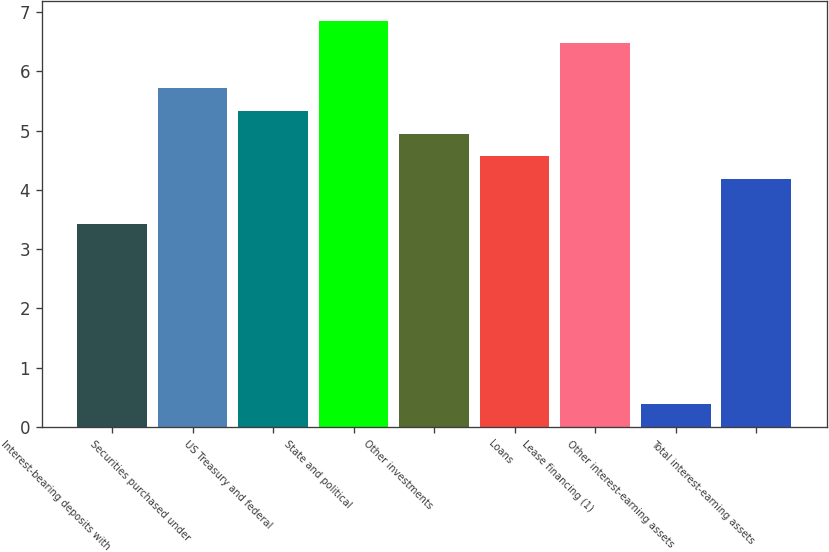Convert chart. <chart><loc_0><loc_0><loc_500><loc_500><bar_chart><fcel>Interest-bearing deposits with<fcel>Securities purchased under<fcel>US Treasury and federal<fcel>State and political<fcel>Other investments<fcel>Loans<fcel>Lease financing (1)<fcel>Other interest-earning assets<fcel>Total interest-earning assets<nl><fcel>3.43<fcel>5.71<fcel>5.33<fcel>6.85<fcel>4.95<fcel>4.57<fcel>6.47<fcel>0.39<fcel>4.19<nl></chart> 